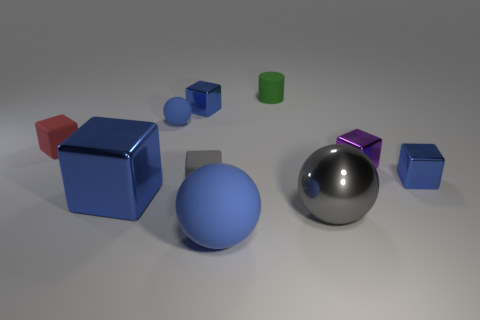How do the textures of the objects influence the perception of colors seen in the image? The textures can significantly affect color perception. In this image, the matte surfaces absorb more light, resulting in a diffused reflection that makes the colors seem more even and less shiny. On the other hand, the metallic objects have smooth surfaces that reflect light more sharply, making their colors appear more vibrant and introducing highlights and reflections that can alter the color's appearance. 